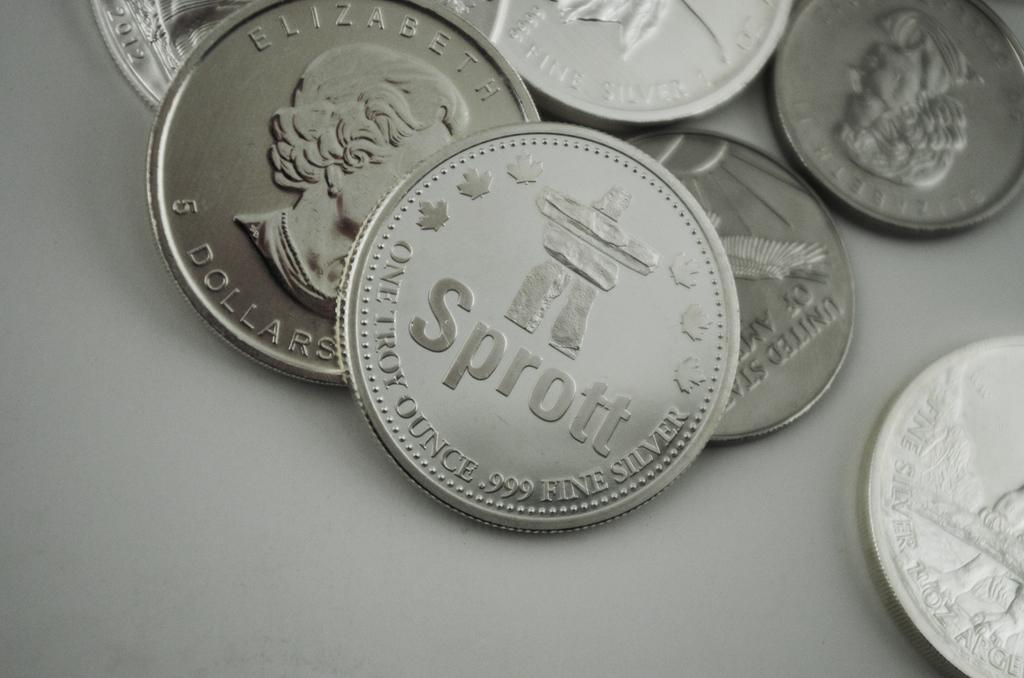Provide a one-sentence caption for the provided image. A lot of coins on a table and one with the word Sprott on it. 